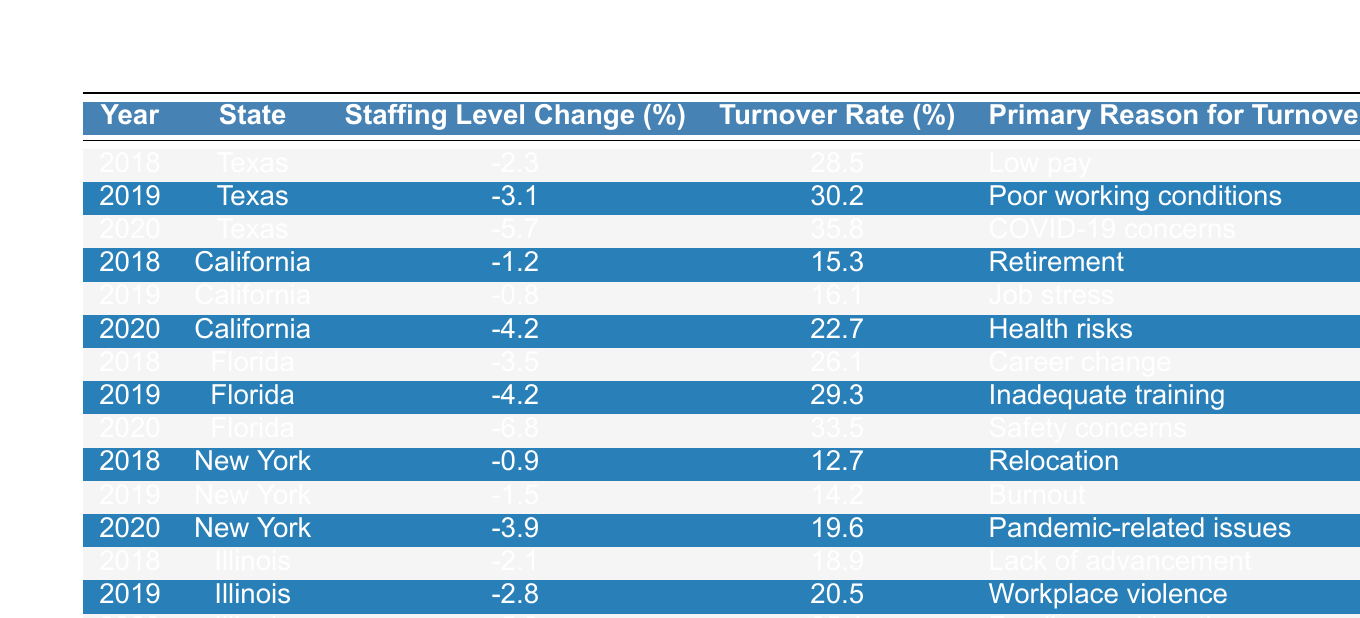What was the turnover rate in Florida in 2020? According to the table, the turnover rate in Florida for the year 2020 is stated directly as 33.5%.
Answer: 33.5% Which state had the highest turnover rate in 2020? By comparing the turnover rates in 2020 from all states, Florida has the highest rate at 33.5%, followed by Texas at 35.8%
Answer: Florida What is the percentage change in staffing levels for Texas from 2019 to 2020? The staffing levels in Texas were -3.1% in 2019 and -5.7% in 2020. The change can be calculated by subtracting -3.1 from -5.7, which gives us a difference of -2.6%
Answer: -2.6% In which year did California have the smallest staffing level change? The smallest staffing level change for California was in 2019, where it was -0.8%.
Answer: 2019 What are the top two primary reasons for turnover in Texas from 2018 to 2020? From the table, the primary reasons for turnover in Texas are "Low pay" in 2018 and "COVID-19 concerns" in 2020. These two are the most significant during this period.
Answer: Low pay and COVID-19 concerns What is the average turnover rate for New York over the years listed? To find the average turnover rate for New York, add the rates for 2018 (12.7), 2019 (14.2), and 2020 (19.6): 12.7 + 14.2 + 19.6 = 46.5. Then dividing by 3 gives an average of approximately 15.5%
Answer: 15.5% Did any state experience an increase in turnover rates from 2018 to 2020? When examining the turnover rates, Texas, Florida, Illinois, and New York all show an increase in turnover rates from 2018 to 2020. Thus, the answer is yes.
Answer: Yes Which state has the most reasons for turnover listed in 2020? In 2020, all states listed a single primary reason for turnover. Therefore, there isn’t a particular state with more reasons; they all have one.
Answer: None What was the overall trend in staffing levels across all states from 2018 to 2020? Most states show a decline in staffing level percentages from 2018 to 2020, indicating a negative trend in staffing levels across the specified years.
Answer: Declining trend Which state had the least turnover rate in 2019? Looking at the turnover rates for 2019, California had the least turnover rate at 16.1%.
Answer: California 